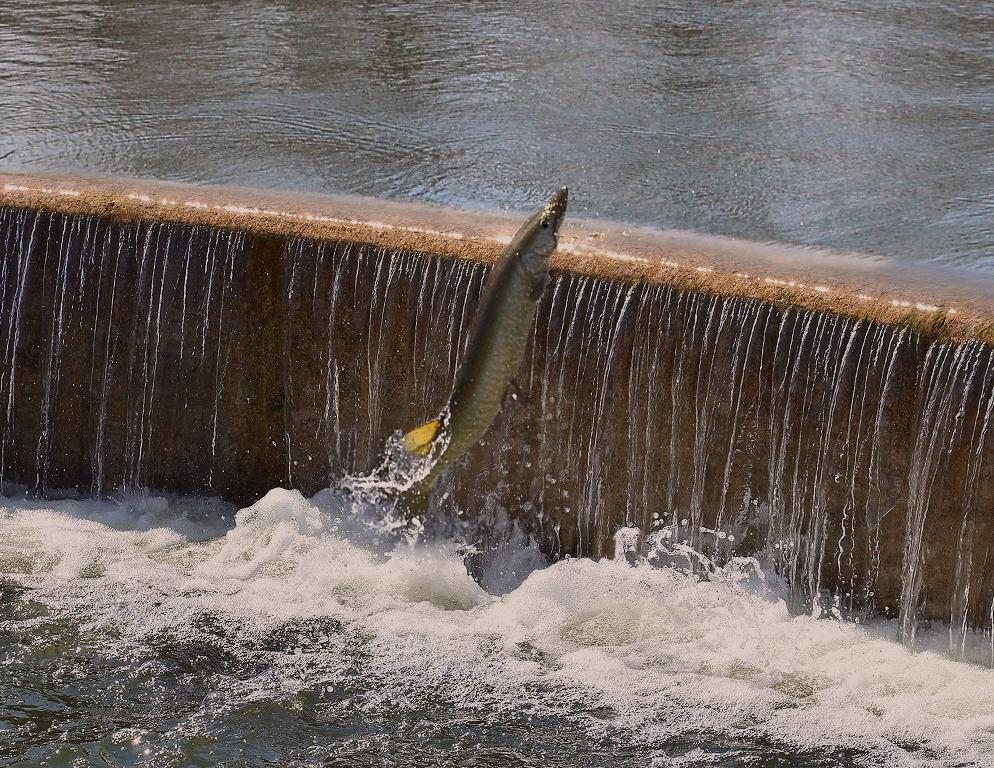What natural feature is depicted in the picture? There is a waterfall in the picture. Is there any wildlife present in the image? Yes, a fish is coming out of the waterfall. What color is the fish in the image? The fish is gray in color. How many bridges can be seen crossing the waterfall in the image? There are no bridges present in the image; it only features a waterfall and a fish. What type of oven is used to cook the fish in the image? There is no oven present in the image, as it is a natural scene with a waterfall and a fish. 